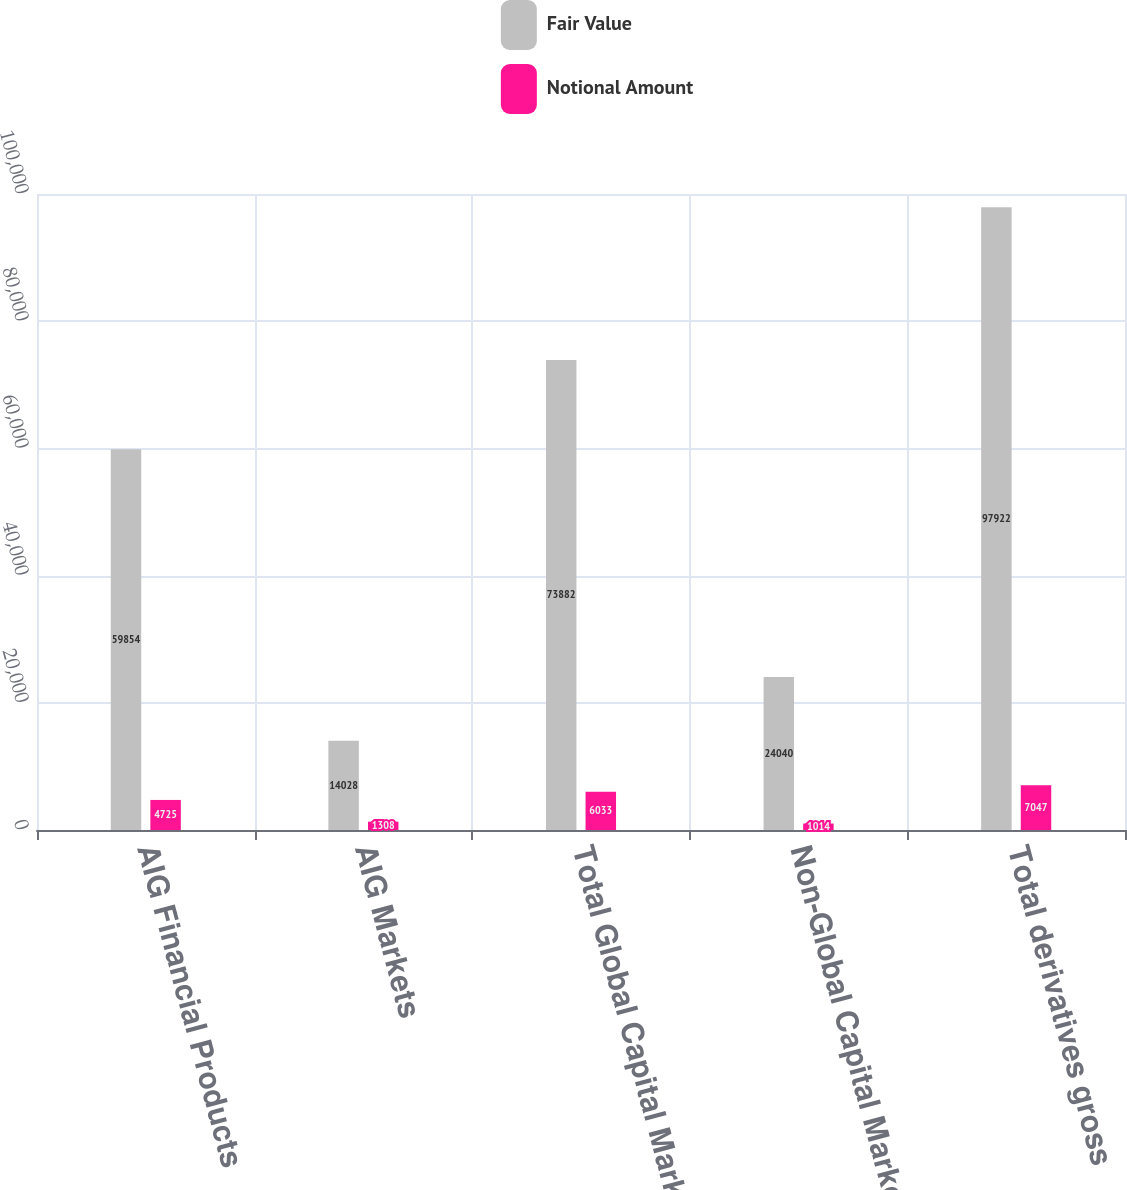<chart> <loc_0><loc_0><loc_500><loc_500><stacked_bar_chart><ecel><fcel>AIG Financial Products<fcel>AIG Markets<fcel>Total Global Capital Markets<fcel>Non-Global Capital Markets<fcel>Total derivatives gross<nl><fcel>Fair Value<fcel>59854<fcel>14028<fcel>73882<fcel>24040<fcel>97922<nl><fcel>Notional Amount<fcel>4725<fcel>1308<fcel>6033<fcel>1014<fcel>7047<nl></chart> 